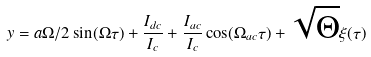Convert formula to latex. <formula><loc_0><loc_0><loc_500><loc_500>y = a \Omega / 2 \sin ( \Omega \tau ) + \frac { I _ { d c } } { I _ { c } } + \frac { I _ { a c } } { I _ { c } } \cos ( \Omega _ { a c } \tau ) + \sqrt { \Theta } \xi ( \tau )</formula> 